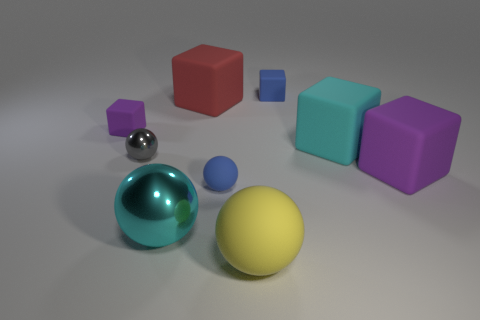Subtract 1 balls. How many balls are left? 3 Subtract all blue blocks. How many blocks are left? 4 Subtract all small blue blocks. How many blocks are left? 4 Subtract all green cubes. Subtract all purple cylinders. How many cubes are left? 5 Add 1 cyan matte blocks. How many objects exist? 10 Subtract all cubes. How many objects are left? 4 Add 8 small green cubes. How many small green cubes exist? 8 Subtract 0 gray cylinders. How many objects are left? 9 Subtract all tiny metallic objects. Subtract all large rubber balls. How many objects are left? 7 Add 1 small purple rubber objects. How many small purple rubber objects are left? 2 